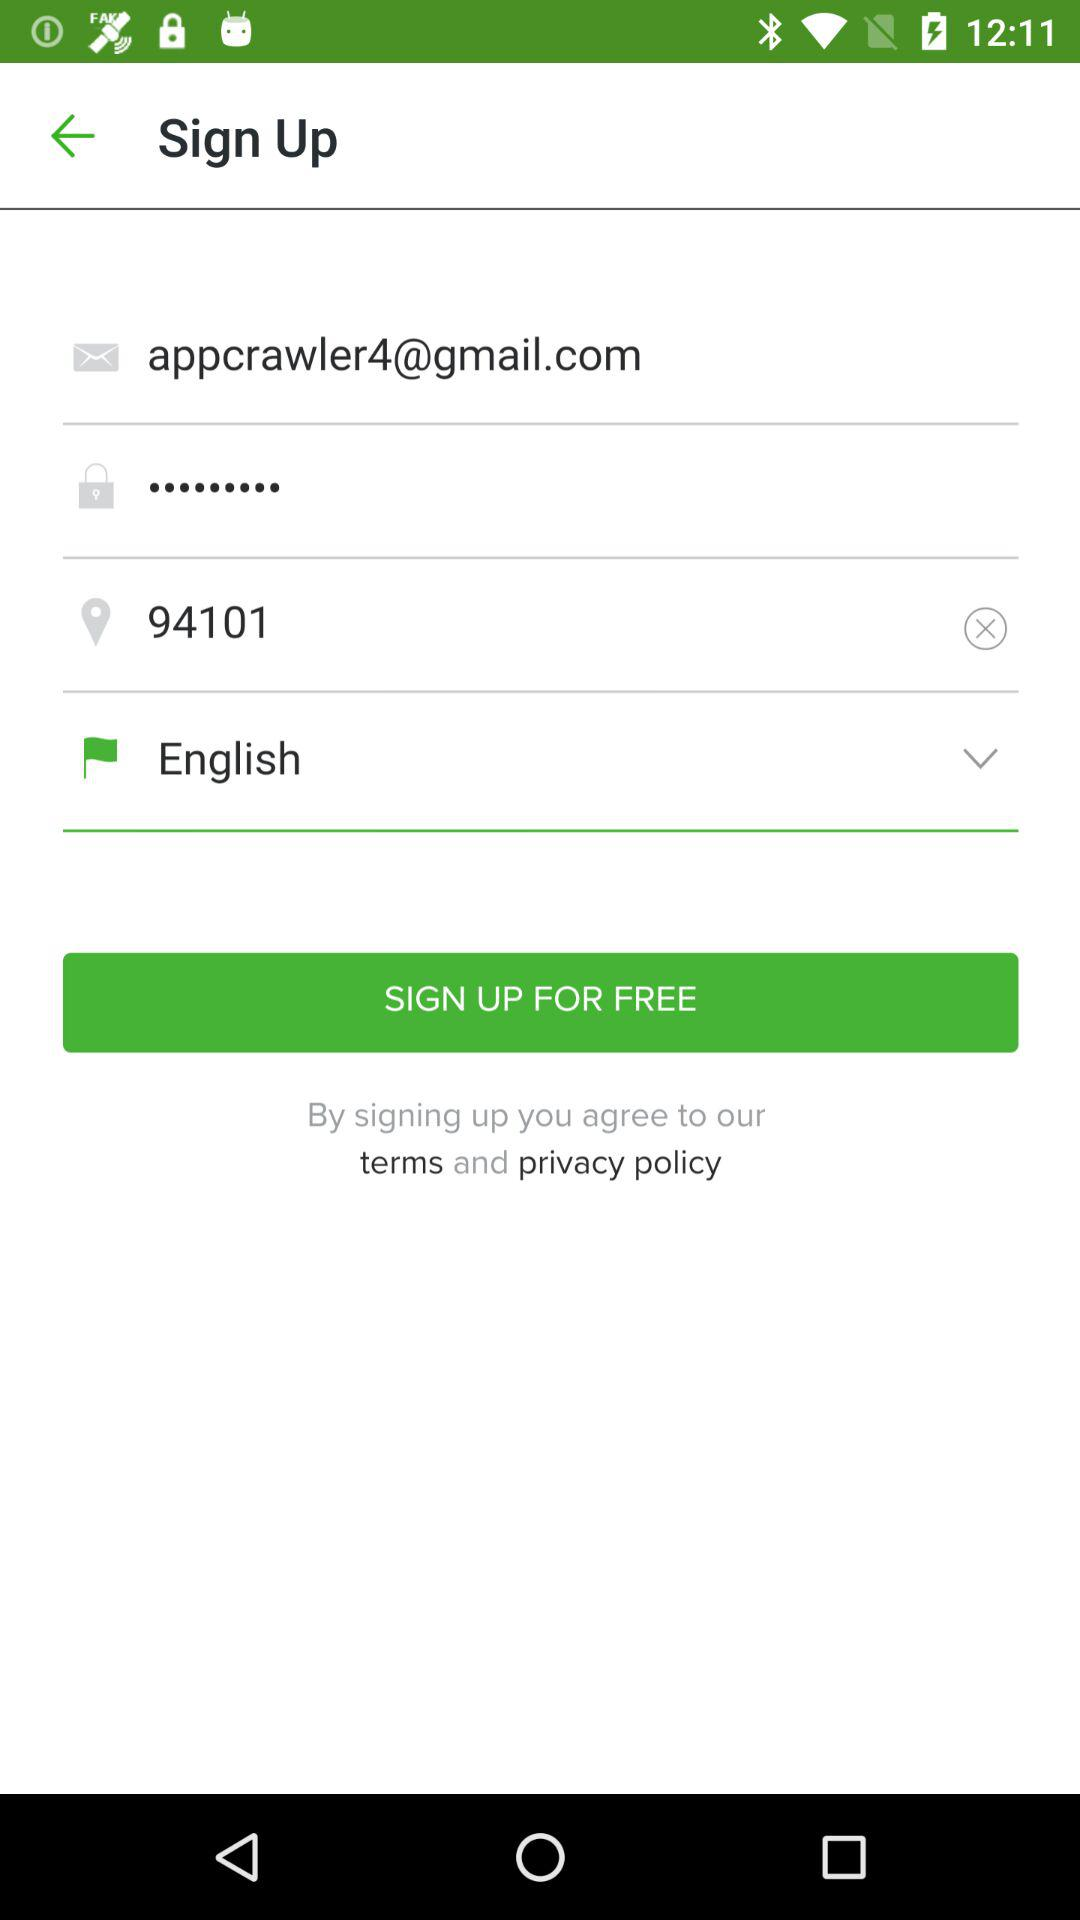What is the email address? The email address is appcrawler4@gmail.com. 